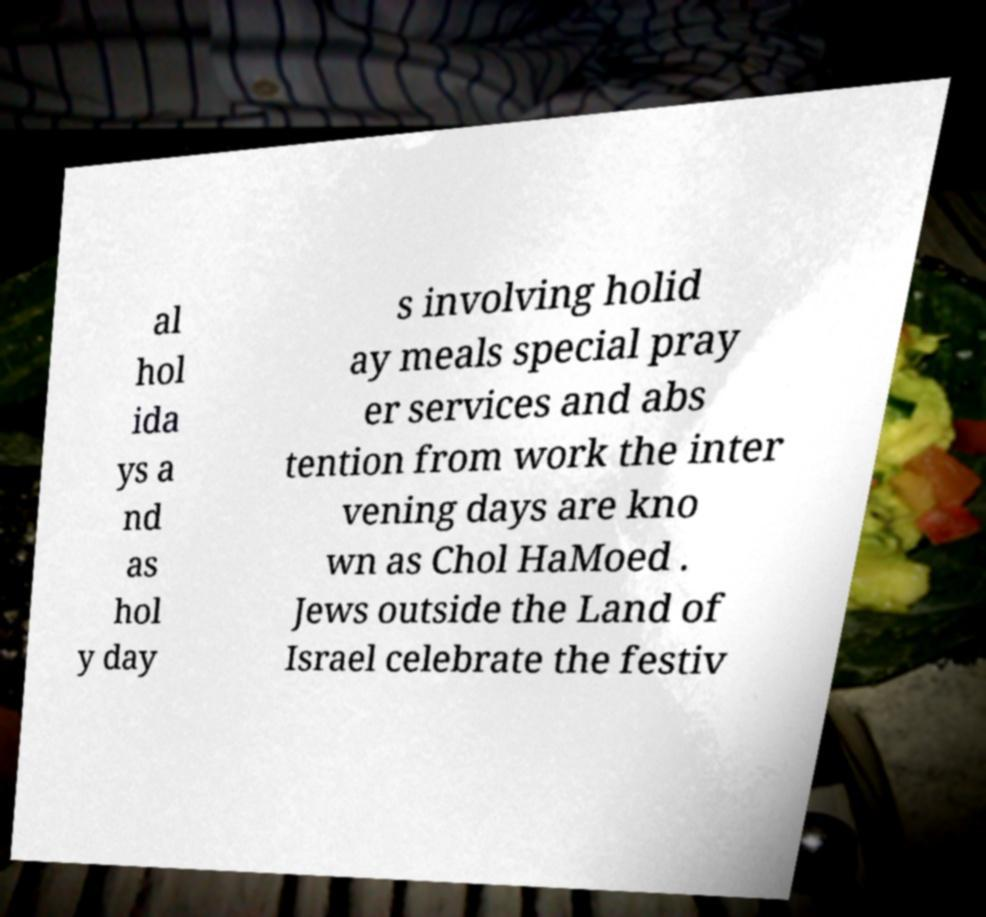I need the written content from this picture converted into text. Can you do that? al hol ida ys a nd as hol y day s involving holid ay meals special pray er services and abs tention from work the inter vening days are kno wn as Chol HaMoed . Jews outside the Land of Israel celebrate the festiv 